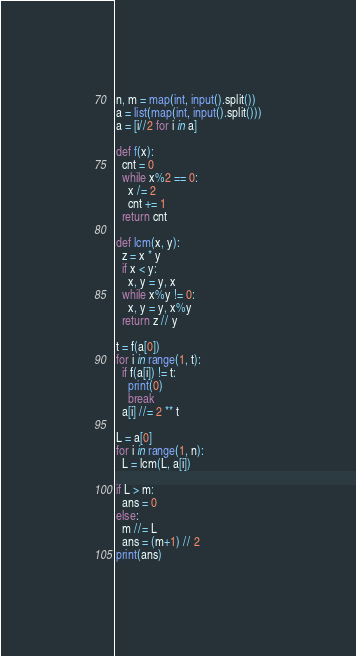<code> <loc_0><loc_0><loc_500><loc_500><_Python_>n, m = map(int, input().split())
a = list(map(int, input().split()))
a = [i//2 for i in a]

def f(x):
  cnt = 0
  while x%2 == 0:
    x /= 2
    cnt += 1
  return cnt

def lcm(x, y):
  z = x * y
  if x < y:
    x, y = y, x
  while x%y != 0:
    x, y = y, x%y
  return z // y

t = f(a[0])
for i in range(1, t):
  if f(a[i]) != t:
    print(0)
    break
  a[i] //= 2 ** t

L = a[0]
for i in range(1, n):
  L = lcm(L, a[i])

if L > m:
  ans = 0
else:
  m //= L
  ans = (m+1) // 2
print(ans)</code> 